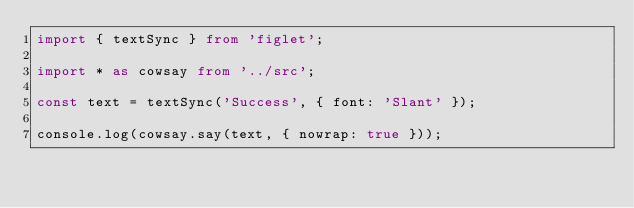Convert code to text. <code><loc_0><loc_0><loc_500><loc_500><_TypeScript_>import { textSync } from 'figlet';

import * as cowsay from '../src';

const text = textSync('Success', { font: 'Slant' });

console.log(cowsay.say(text, { nowrap: true }));
</code> 